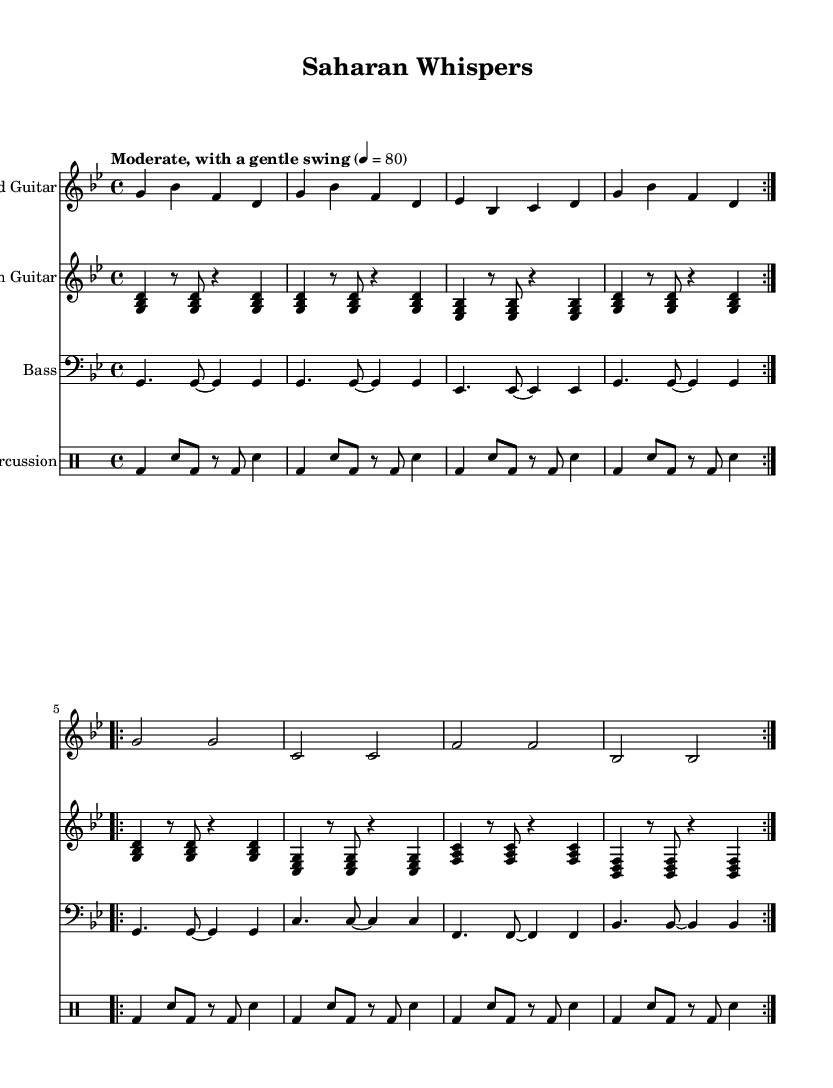What is the key signature of this music? The key signature is indicated by the presence of two flats in the music, which corresponds to the key of G minor.
Answer: G minor What is the time signature of this music? The time signature is stated at the beginning of the music, showing a 4 over 4, which means there are four beats in each measure.
Answer: 4/4 What tempo is indicated for this piece? The tempo is specified as "Moderate, with a gentle swing," and set at a metronome marking of 80 beats per minute.
Answer: 80 How many measures are there in the lead guitar section? By counting the repeated sections in the lead guitar part, each section has 8 measures (4 per repeat, 2 repeats), totaling 16 measures.
Answer: 16 What type of percussion is used in this piece? The percussion part is defined in a specialized mode, labeled with "bd" for bass drum and "sn" for snare, indicating a blend of these two kinds of drums.
Answer: Bass drum and snare Which cultural element does this music primarily evoke? The overall theme and instruments used, such as guitars and percussion, reflect the nomadic Tuareg culture, known for its distinct style of desert blues.
Answer: Nomadic Tuareg culture What is a distinctive feature of the bass part in this composition? The bass part consists mainly of dotted quarter notes and eighth notes, which creates a flowing rhythm characteristic of desert blues music from Mali.
Answer: Dotted quarter notes and eighth notes 